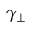<formula> <loc_0><loc_0><loc_500><loc_500>\gamma _ { \perp }</formula> 